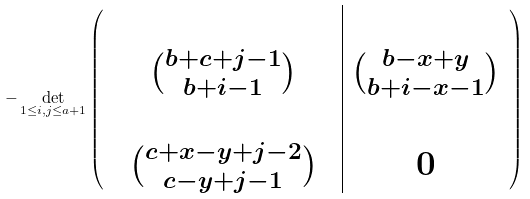Convert formula to latex. <formula><loc_0><loc_0><loc_500><loc_500>- \det _ { 1 \leq i , j \leq a + 1 } \left ( \begin{array} { c c c | c } & & & \\ & \binom { b + c + j - 1 } { b + i - 1 } & & \binom { b - x + y } { b + i - x - 1 } \\ & & & \\ & \binom { c + x - y + j - 2 } { c - y + j - 1 } & & 0 \end{array} \right )</formula> 